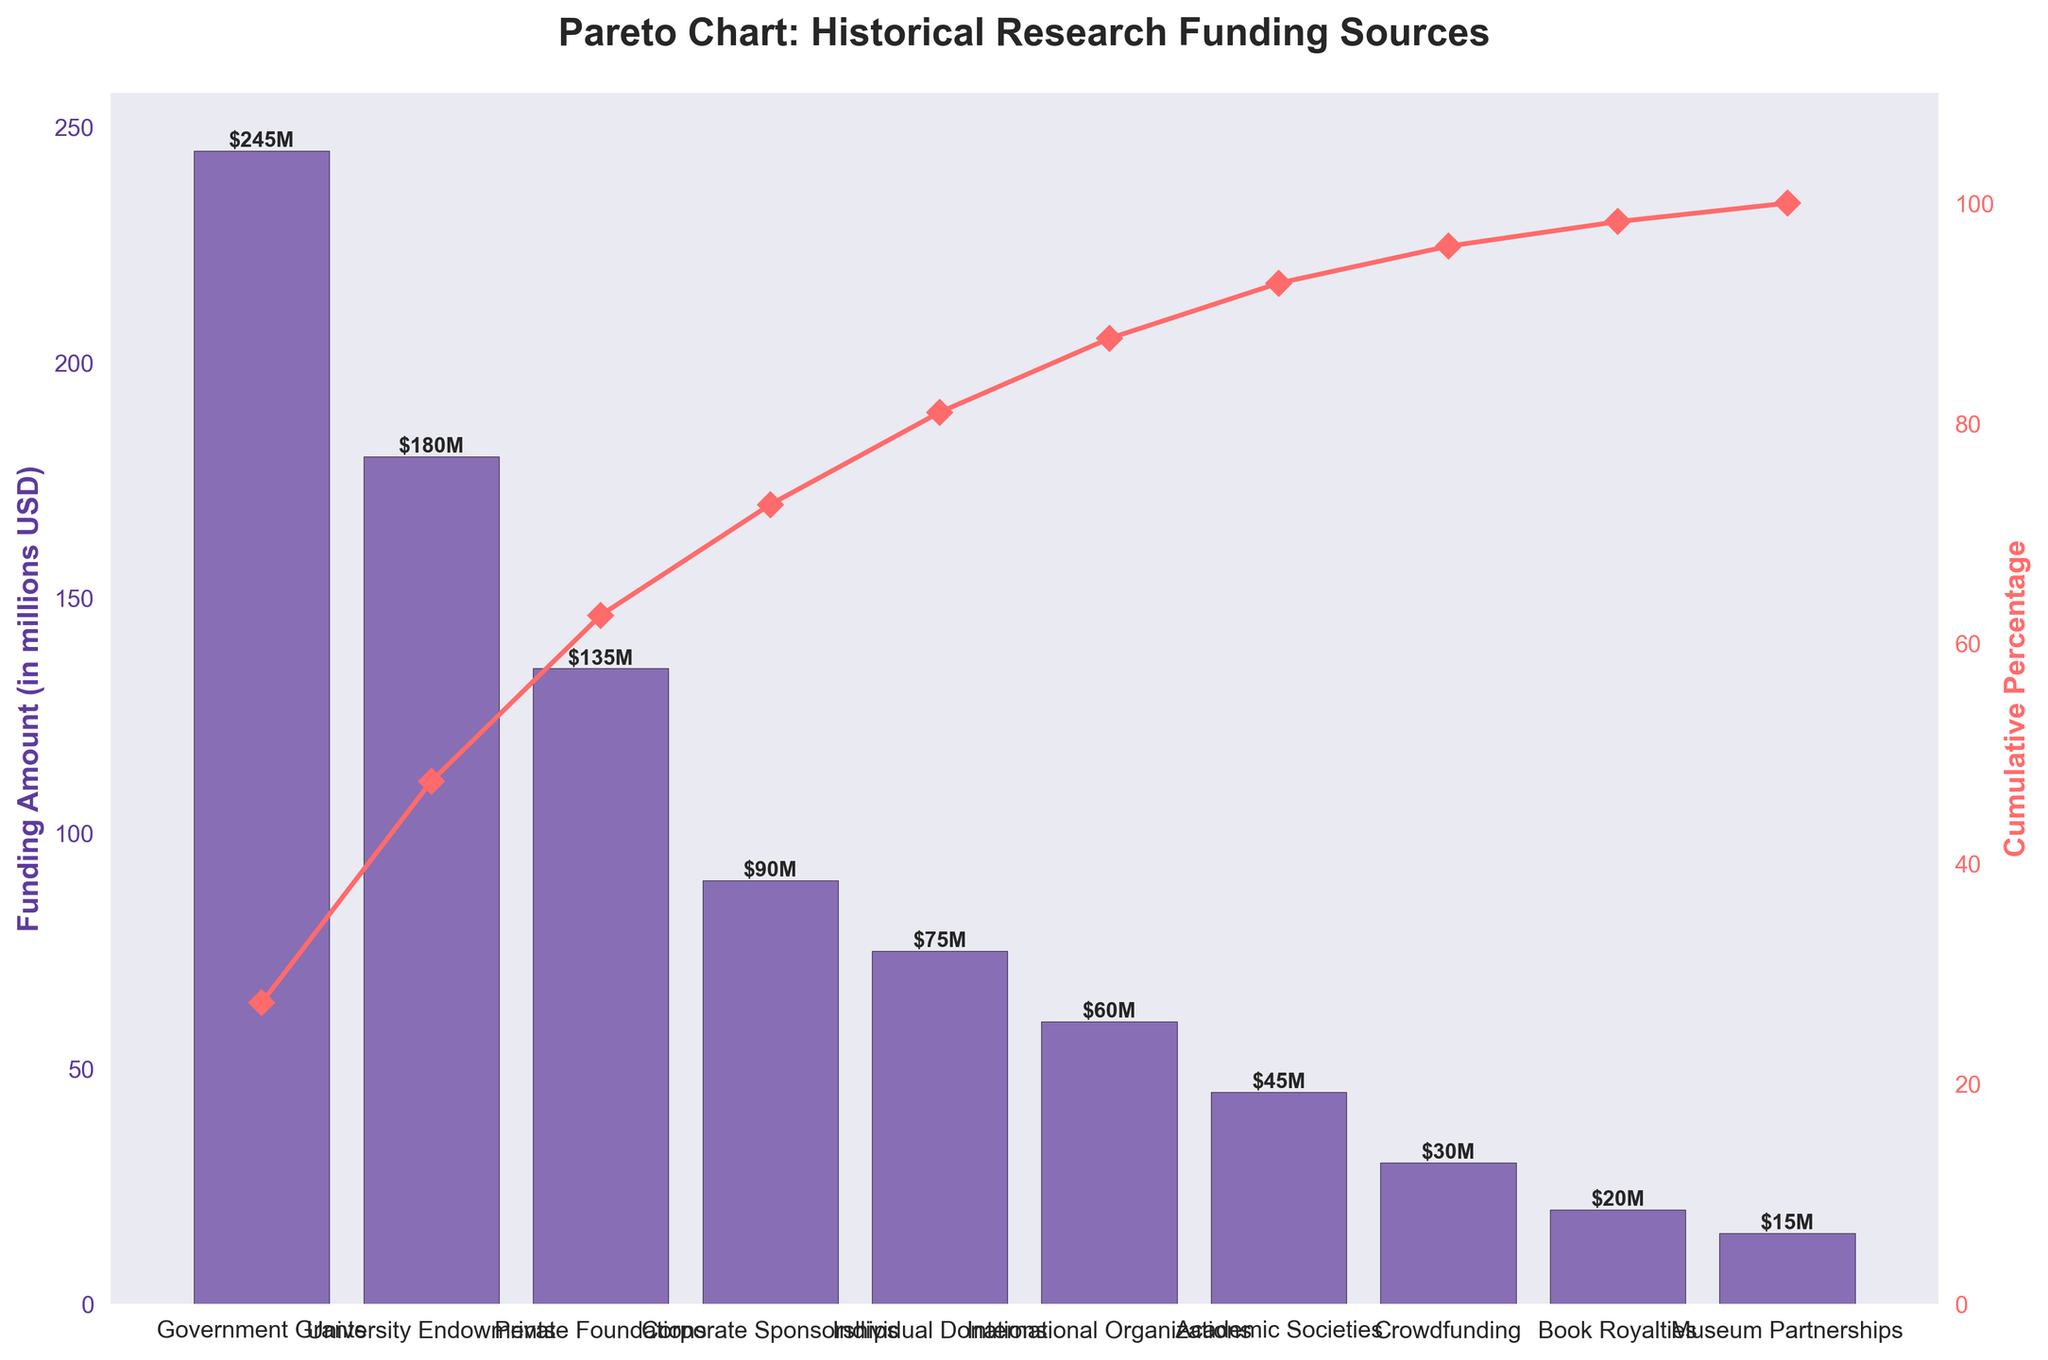What is the title of the Pareto chart? The title is displayed at the top of the chart. It reads "Pareto Chart: Historical Research Funding Sources".
Answer: Pareto Chart: Historical Research Funding Sources Which category has the highest funding amount? The category with the tallest bar on the chart represents the highest funding amount, which is "Government Grants" at $245 million.
Answer: Government Grants What is the cumulative percentage for University Endowments? The cumulative percentage is shown by the red line and point markers. For University Endowments, it is approximately 51%.
Answer: 51% How much is the total funding amount represented in the chart? To find the total, sum all the funding amounts: 245 + 180 + 135 + 90 + 75 + 60 + 45 + 30 + 20 + 15 = 895 million USD.
Answer: 895 million USD Which category's funding amount is closest to the median of all categories? To find the median, sort all funding amounts and find the middle value. Here, the sorted amounts are: 15, 20, 30, 45, 60, 75, 90, 135, 180, 245. The median is therefore (75 + 90) / 2 = 82.5 million USD. The closest category is "Corporate Sponsorships" at 90 million USD.
Answer: Corporate Sponsorships What are the cumulative percentages of the top three categories combined? Verify the cumulative percentage at the top three bars: "Government Grants", "University Endowments", and "Private Foundations". The cumulative percentage for the first three bars is around 78%.
Answer: 78% By what percentage do Government Grants exceed Corporate Sponsorships? Calculate the difference between Government Grants and Corporate Sponsorships and then find the percentage relative to Corporate Sponsorships: (245 - 90) / 90 * 100 ≈ 172.22%.
Answer: 172.22% How many categories are presented in the chart? Count the total number of unique categories represented on the x-axis. There are 10 categories.
Answer: 10 Which of the categories cumulatively reach over 90% of the total funding amount? Check the cumulative percentage to identify categories cumulatively exceeding 90%. These are "Government Grants", "University Endowments", "Private Foundations", and "Corporate Sponsorships" reaching around 90% together.
Answer: Government Grants, University Endowments, Private Foundations, Corporate Sponsorships What is the funding amount displayed at the lowest point of the chart? The shortest bar represents the lowest funding amount, which is "Museum Partnerships" at $15 million.
Answer: 15 million USD 